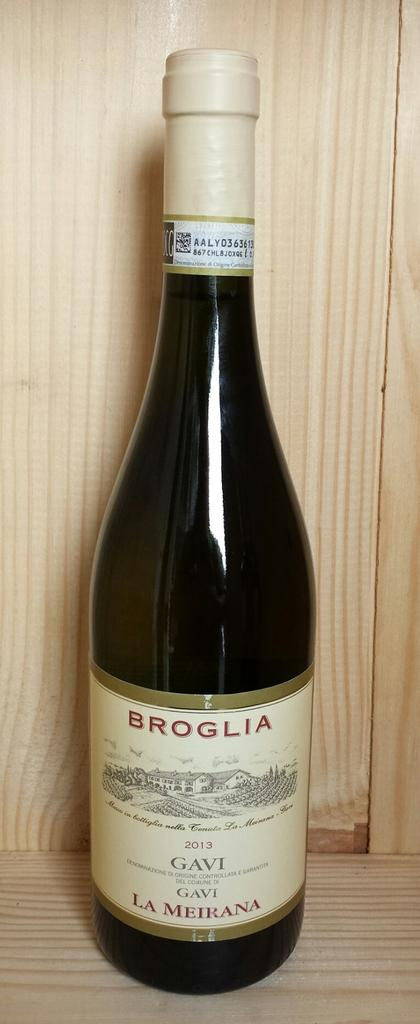<image>
Relay a brief, clear account of the picture shown. A bottle of wine that says Broglia is on a wooden shelf. 